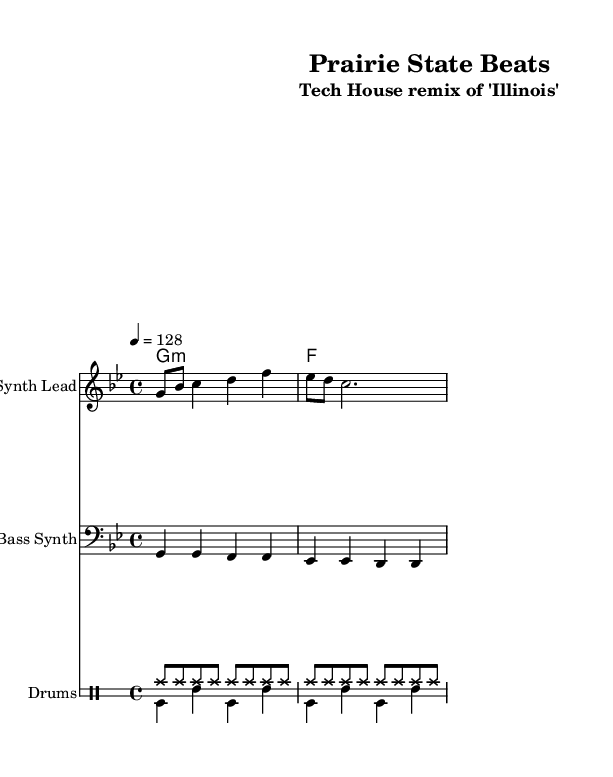What is the key signature of this music? The key signature is G minor, indicated by the one flat on the staff (B flat).
Answer: G minor What is the time signature of this piece? The time signature is 4/4, meaning there are four beats in each measure, and each quarter note gets one beat.
Answer: 4/4 What is the tempo marking for this piece? The tempo marking indicates a speed of 128 beats per minute, as noted in the tempo instruction.
Answer: 128 How many measures are in the melody section? The melody section contains two measures, as indicated by the grouping of notes and vertical lines separating them.
Answer: 2 Which instrument is indicated for the melody in this score? The score indicates the instrument for the melody is a "Synth Lead," specified at the beginning of that staff section.
Answer: Synth Lead What type of rhythm pattern is used in the 'drumsUp' section? The 'drumsUp' section consists of eight hi-hat notes played in succession, indicating a steady driving rhythm typical of house music.
Answer: Hi-hat How many different instruments are featured in this arrangement? The arrangement features three different instruments: Synth Lead, Bass Synth, and Drums.
Answer: 3 